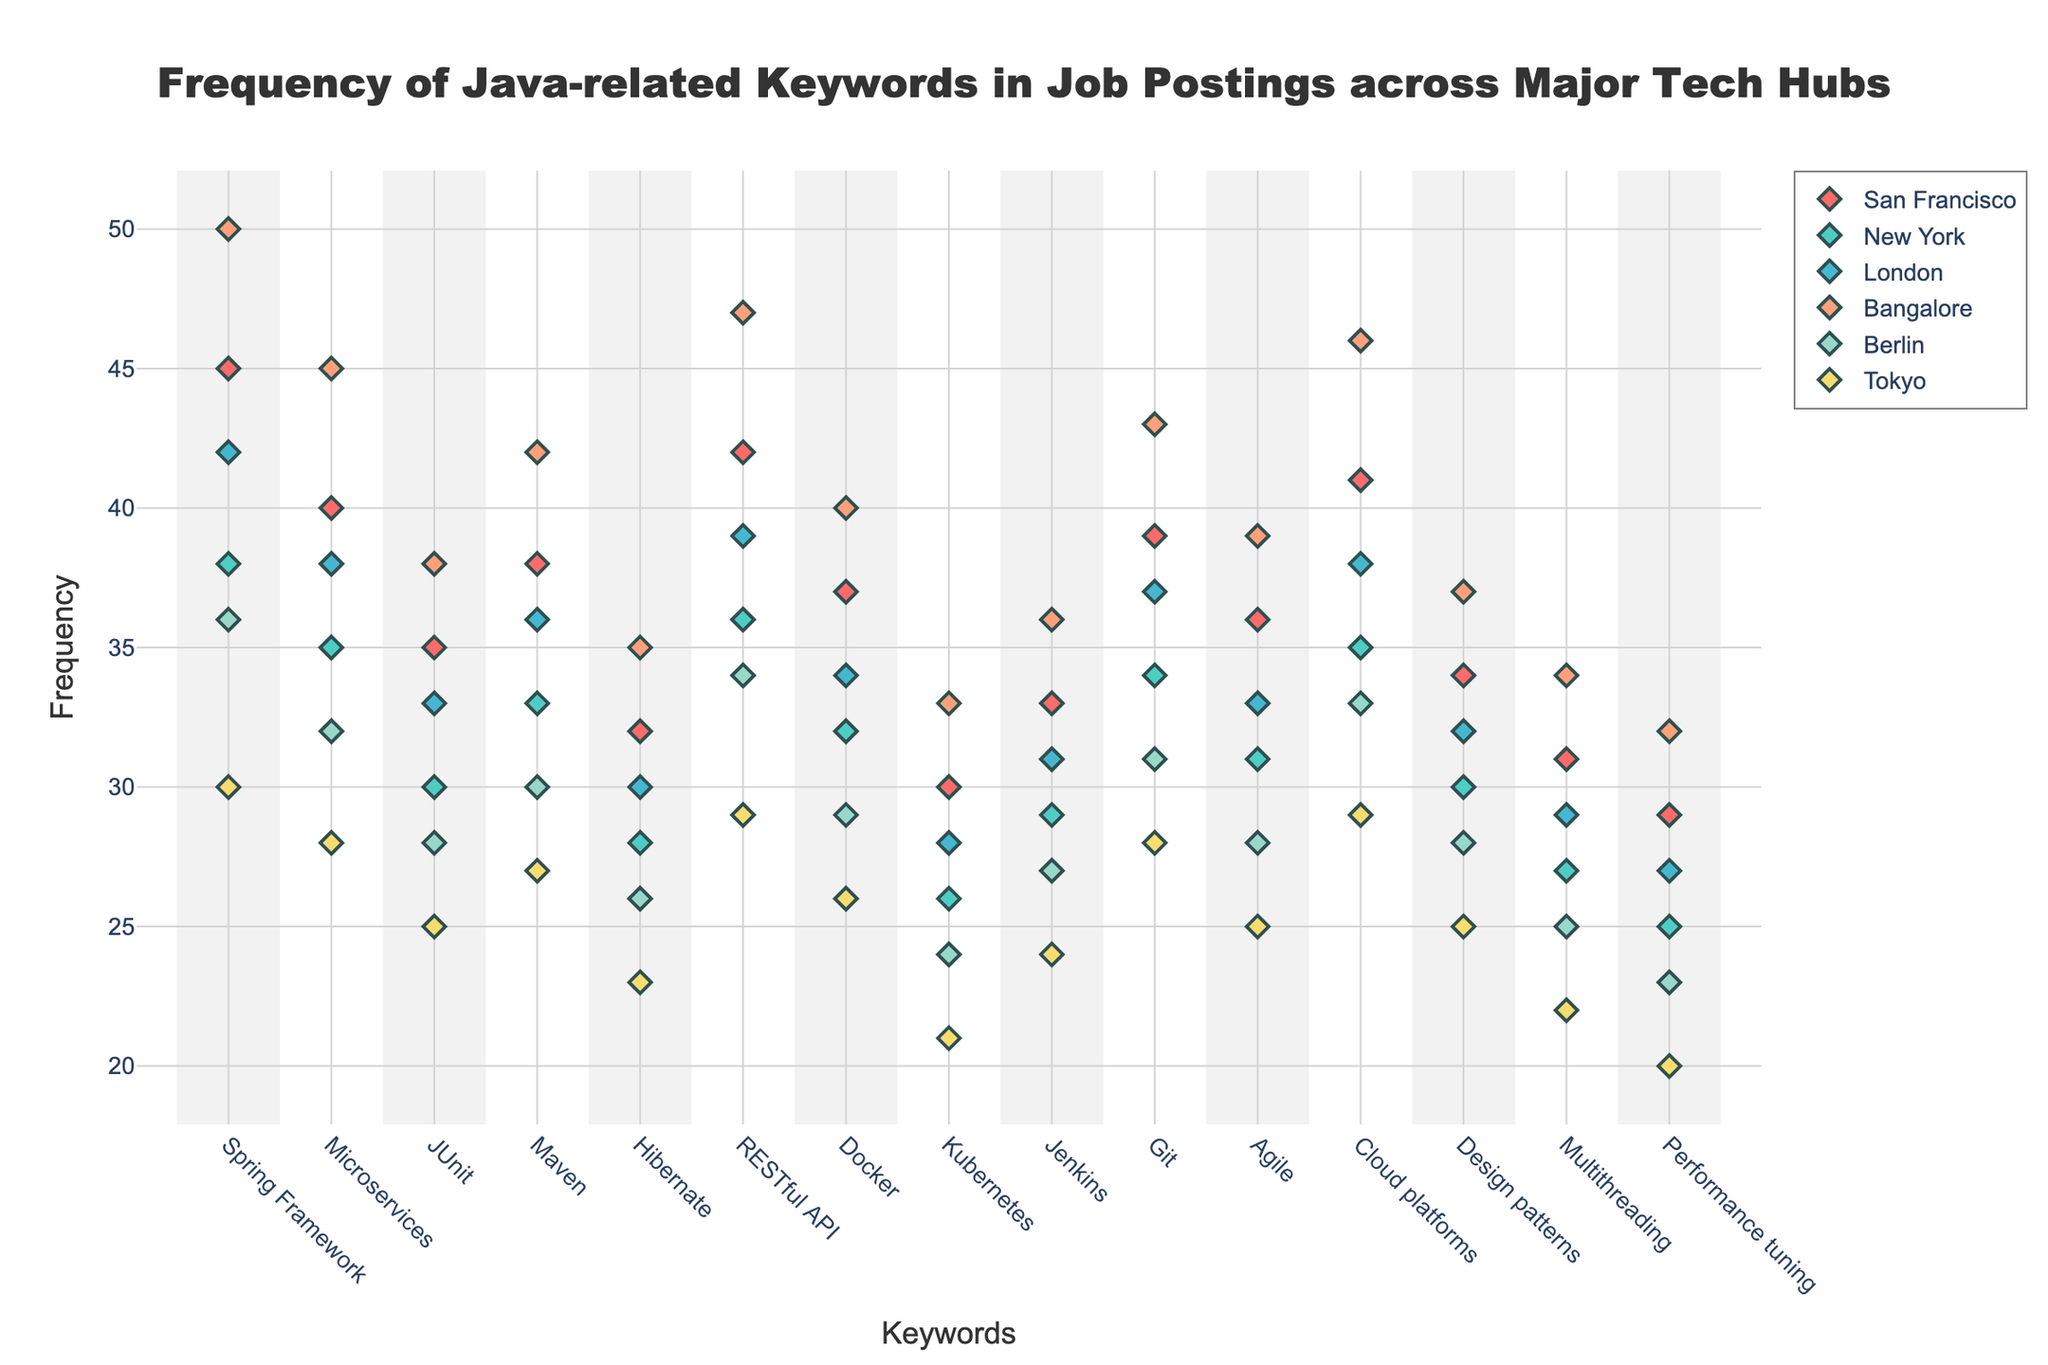what is the color of the markers representing San Francisco? The color of the markers for each city is defined in the code. For San Francisco, the specified color is '#FF6B6B', which represents a red-like color.
Answer: Red-like Which keyword has the highest frequency in Bangalore? To answer this, look at the y-values for the Bangalore markers across all keywords. The keyword "Spring Framework" has the highest frequency at 50.
Answer: Spring Framework How does the frequency of "Microservices" in New York compare to Berlin? Look at the markers representing "Microservices" for New York and Berlin. New York has a frequency of 35, while Berlin has 32. Hence, New York's frequency is higher.
Answer: New York > Berlin What is the average frequency of "Docker" across all cities? Sum the frequencies of "Docker" from all cities: 37 (San Francisco) + 32 (New York) + 34 (London) + 40 (Bangalore) + 29 (Berlin) + 26 (Tokyo) = 198. Then, divide by the number of cities (6). The average is 198 / 6 = 33.
Answer: 33 Which city has the lowest frequency for "JUnit"? Look for the marker that has the lowest y-value corresponding to "JUnit". Tokyo has the lowest frequency at 25 for "JUnit".
Answer: Tokyo Is the frequency of "RESTful API" in Berlin greater than "Git" in Tokyo? Check the y-values for "RESTful API" in Berlin (34) and "Git" in Tokyo (28). 34 is greater than 28.
Answer: Yes What is the range of frequencies for "Hibernate" across all cities? Find the minimum and maximum frequencies for "Hibernate". The minimum is in Tokyo (23) and the maximum is in Bangalore (35). The range is 35 - 23 = 12.
Answer: 12 Compare the frequencies of "Cloud platforms" and "Design patterns" in London. Which is higher? Check the markers for "Cloud platforms" and "Design patterns" in London. "Cloud platforms" has a frequency of 38 and "Design patterns" has 32. Therefore, "Cloud platforms" is higher.
Answer: Cloud platforms How many keywords have a frequency of 30 or more in Tokyo? Count the number of markers in Tokyo with a frequency of 30 or more. There are 3 such keywords: "Spring Framework" (30), "RESTful API" (29), and "Cloud platforms" (29).
Answer: 3 